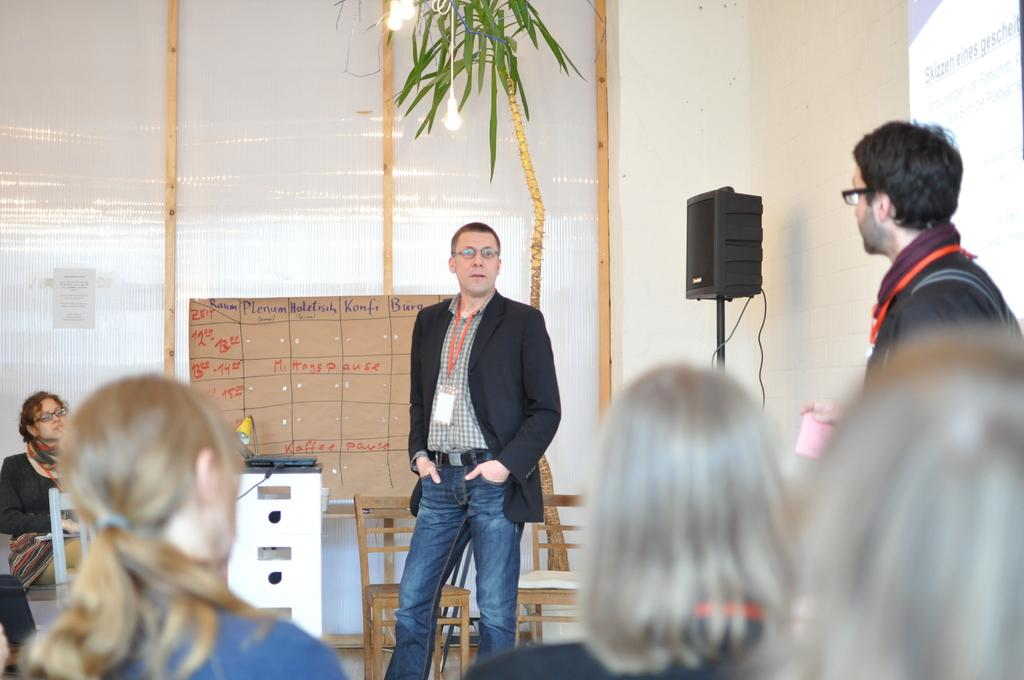How many people are in the image? There is a group of people in the image, but the exact number is not specified. What are the people in the image doing? Some people are seated, while others are standing. What can be seen in the background of the image? There are lights, a speaker, chairs, and a plant in the background of the image. What year is depicted in the image? The image does not depict a specific year; it is a snapshot of a moment in time. Can you identify any veins in the image? There are no veins visible in the image, as it features a group of people and various background elements. 